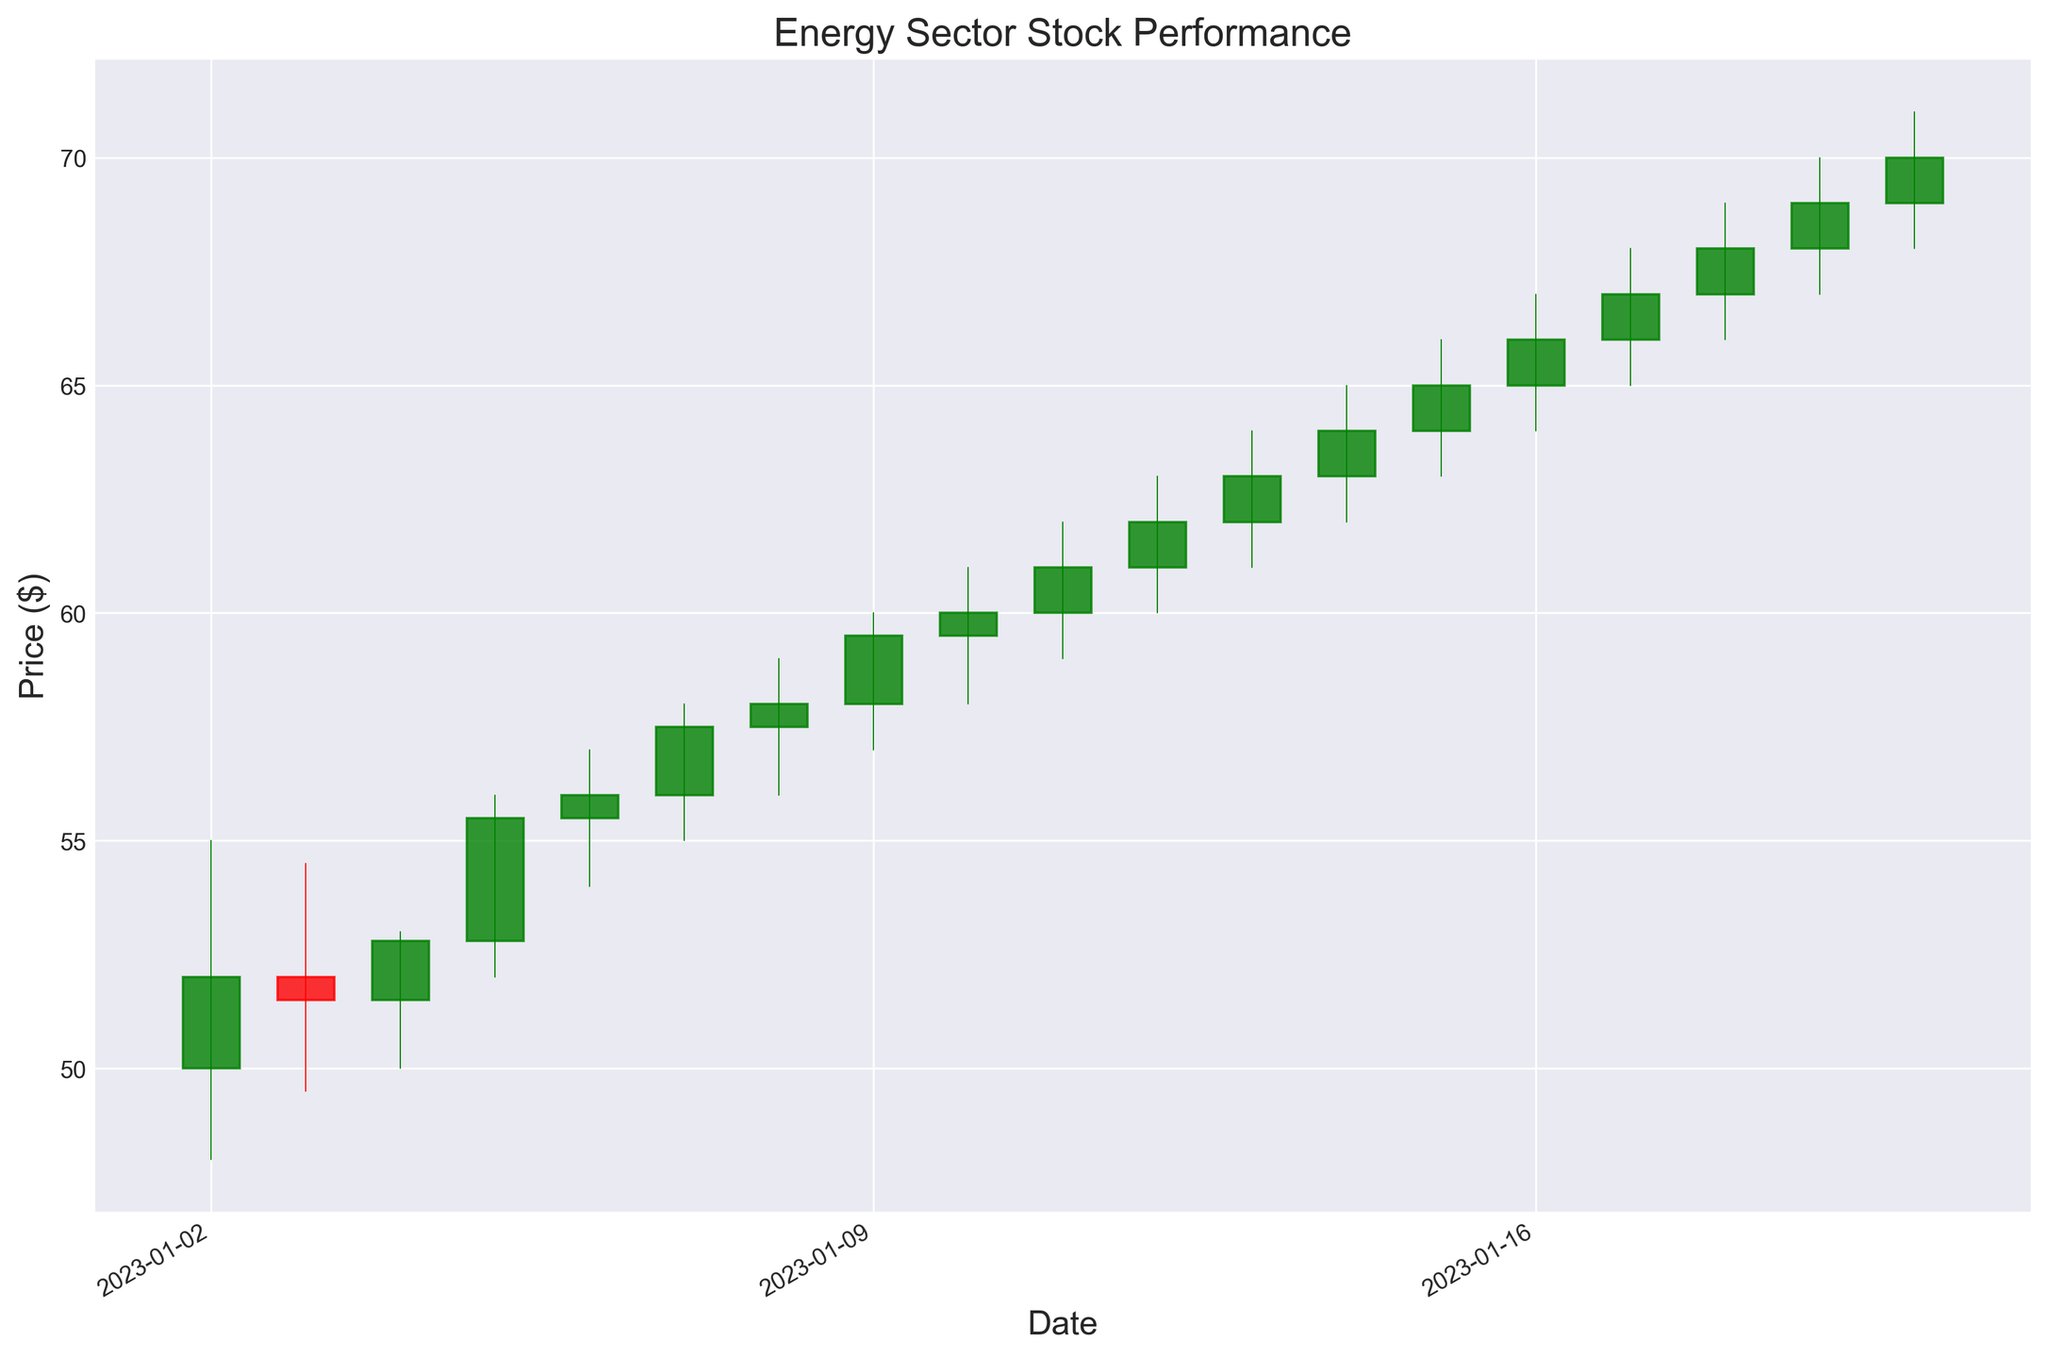What was the highest closing price during the plotted period? Look for the highest point on the closing price line throughout the date range. The highest closing price is at the end of the candlestick for January 20.
Answer: 70.00 Which date had the largest volume of stocks traded? Compare the volume values for each date. The highest volume is recorded on January 20 with 3,100,000.
Answer: January 20 Which day had the largest difference between the opening and closing prices? Calculate the difference (Open - Close) for each day, then determine the maximum value. For January 2, it's the largest difference, which is 50.00 - 52.00.
Answer: January 2 How many days did the closing price go up compared to the previous day? Count the number of days where the close price is higher than the previous day's close. There are several days when the closing price increased the next day.
Answer: 13 What was the average closing price for the last week of the plotted period (January 14 to January 20)? Sum the closing prices from January 14 to January 20, then divide by the number of days (7). (64.00 + 65.00 + 66.00 + 67.00 + 68.00 + 69.00 + 70.00) / 7 gives the average closing price.
Answer: 67.00 Which days had a bearish candlestick (when the closing price is lower than the opening price)? Identify days where the candlestick is red (close < open). January 2, January 3, and January 5 had bearish candlesticks.
Answer: January 2, January 3, January 5 Which date had the highest intraday price range (difference between high and low prices)? Calculate the high - low for each day and compare. For January 2, this range is (55.00 - 48.00).
Answer: January 2 On which day did the closing price first surpass 60 dollars? Find the first date in the series where the closing price exceeds 60. It happened on January 11.
Answer: January 11 